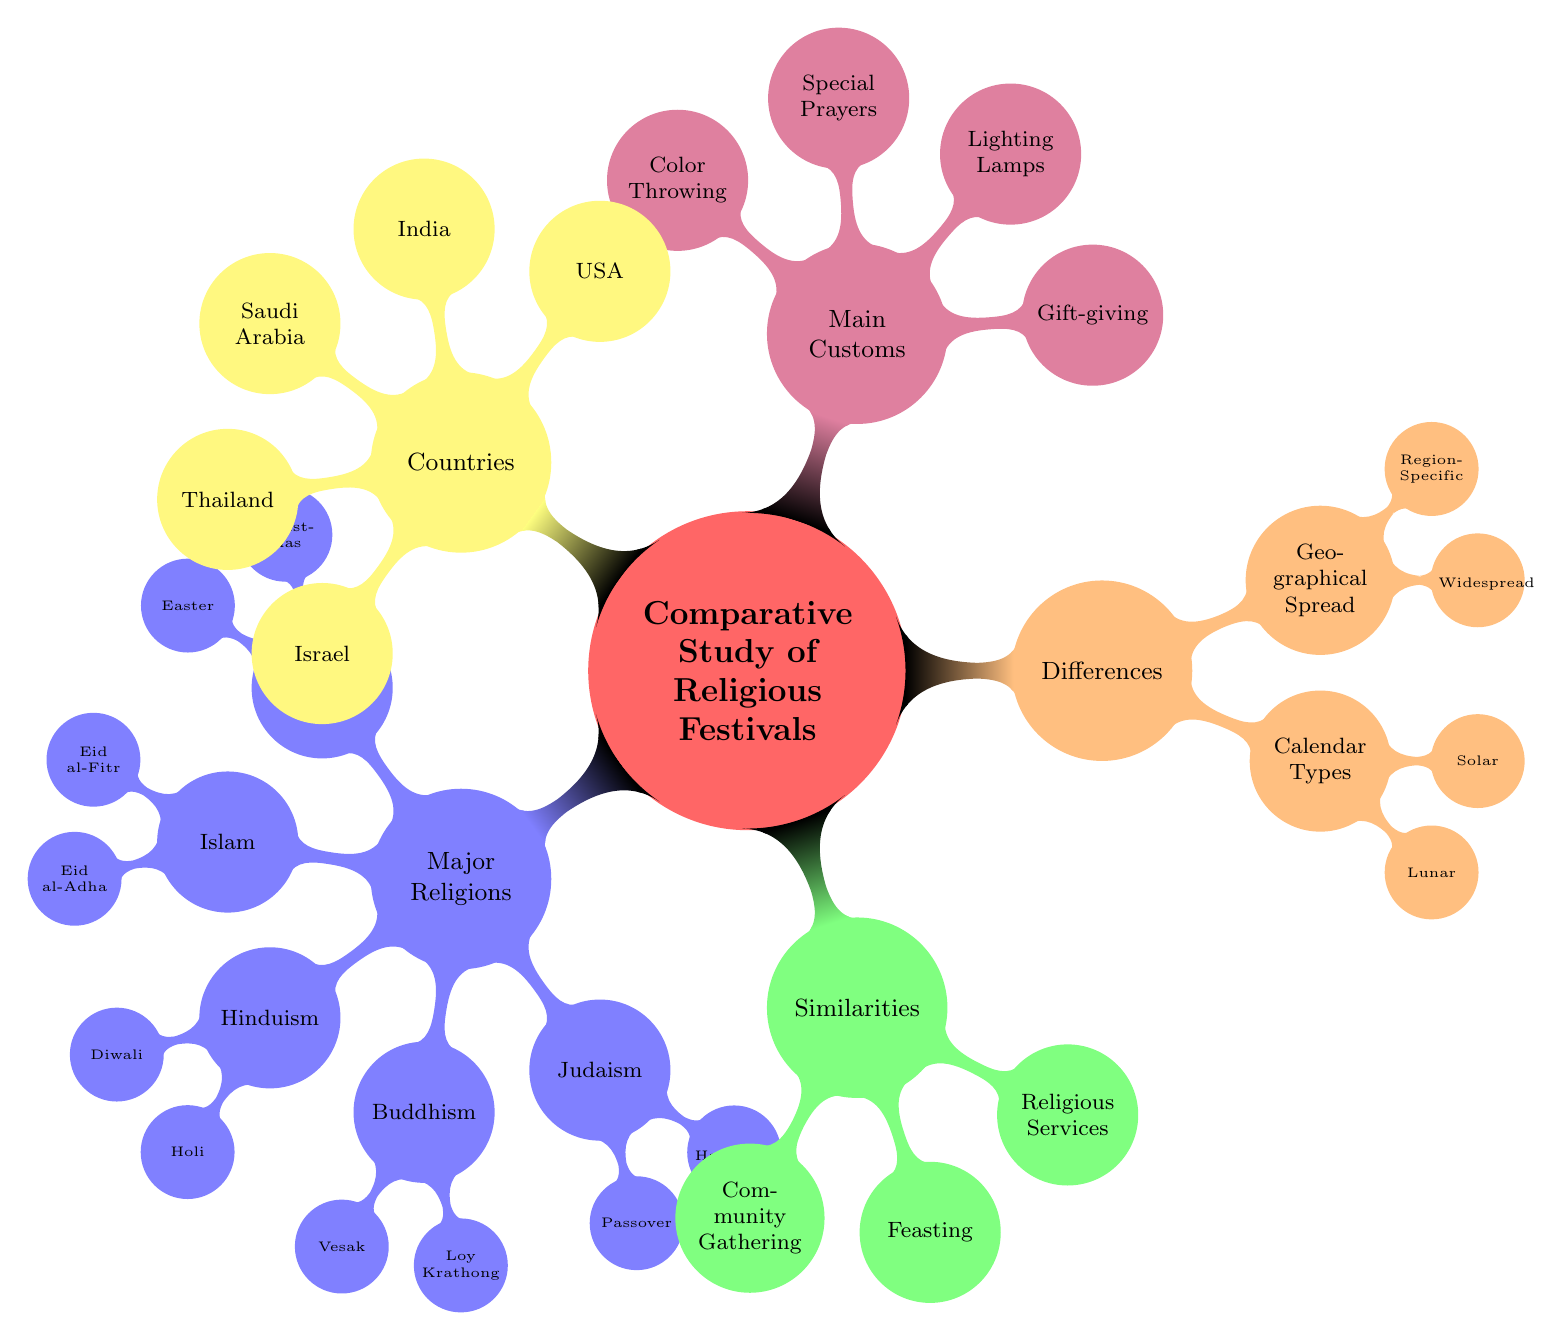What is the date of Christmas? The diagram states that Christmas is celebrated on December 25, as indicated under the Christianity node.
Answer: December 25 Which festival is observed on the full moon of Phalguna? The node for Hinduism shows that Holi is celebrated on the full moon of Phalguna, specifically listed in the Holi child node.
Answer: Holi How many major religions are represented in the diagram? The Major Religions node contains five sub-nodes: Christianity, Islam, Hinduism, Buddhism, and Judaism. Counting these gives a total of five major religions.
Answer: 5 What are the main customs during Diwali? The diagram specifies that the main customs of Diwali include lighting oil lamps, fireworks, and feasts under the Diwali node in the Hinduism section.
Answer: Lighting Oil Lamps, Fireworks, Feasts Which festivals promote community gathering? The Similarities node states that Christmas, Eid al-Fitr, Diwali, and Vesak are recognized for community gathering customs. This can be found in the Community Gathering sub-node.
Answer: Christmas, Eid al-Fitr, Diwali, Vesak What is a key difference between lunar and solar calendar festivals mentioned? The differences included in the Calendar Types node show that Eid al-Fitr, Eid al-Adha, Holi, Vesak, and Hanukkah are lunar, while Christmas and Easter are solar.
Answer: Lunar: Eid al-Fitr, Eid al-Adha, Holi, Vesak, Hanukkah; Solar: Christmas, Easter Which festival is specific to Thailand? The diagram indicates that Loy Krathong, which is mentioned under Buddhism, is the only festival listed that is specific to Thailand.
Answer: Loy Krathong What is the main custom associated with Hanukkah? The budget for Judaism shows that one of the main customs during Hanukkah is lighting the Menorah, specifically stated in the Hanukkah node.
Answer: Lighting the Menorah How many festivals involve feasting as a main custom? Under the Feasting similarity node, the festivals listed are Christmas, Eid al-Adha, Diwali, and Passover, totaling four festivals that involve feasting.
Answer: 4 